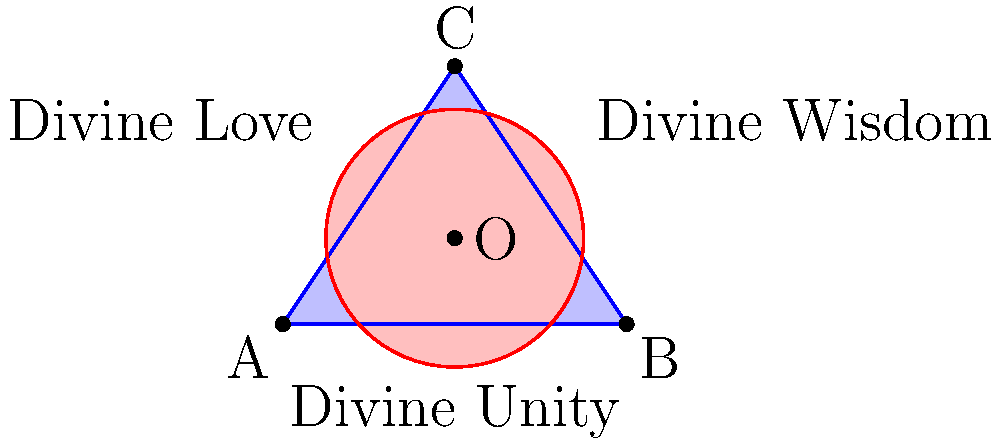In the diagram, triangle ABC represents the Trinity, with each side symbolizing a divine attribute: Unity, Wisdom, and Love. The circle centered at O represents God's infinite nature. If the area of triangle ABC is 6 square units and the radius of the circle is 1.5 units, what is the area of the region where the triangle and circle overlap, rounded to two decimal places? How might this overlapping area represent the interconnectedness of divine principles? Let's approach this step-by-step:

1) First, we need to find the area of the circle:
   Area of circle = $\pi r^2 = \pi (1.5)^2 = 2.25\pi$ square units

2) We're given that the area of the triangle is 6 square units.

3) To find the overlapping area, we need to use the formula:
   Area of overlap = Area of triangle + Area of circle - Area of union

4) To find the area of the union, we need to use the principle of inclusion-exclusion:
   Area of union = Area of triangle + Area of circle - Area of overlap

5) Let x be the area of overlap. Then:
   Area of union = $6 + 2.25\pi - x$

6) The area of union must equal the sum of the individual areas minus the overlap:
   $6 + 2.25\pi - x = 6 + 2.25\pi - x$

7) This equation is always true, regardless of the value of x. To find x, we need additional information or geometric reasoning.

8) Without more specific measurements, we can't calculate the exact overlap. However, from the diagram, we can estimate that about 1/3 of the circle overlaps with the triangle.

9) Estimated area of overlap: $\frac{1}{3} * 2.25\pi \approx 2.36$ square units

This overlapping area represents the interconnectedness of divine principles by showing how Unity, Wisdom, and Love (represented by the triangle) intersect with God's infinite nature (represented by the circle). The overlap suggests that these principles are not isolated but intertwined within the divine nature.
Answer: Approximately 2.36 square units 